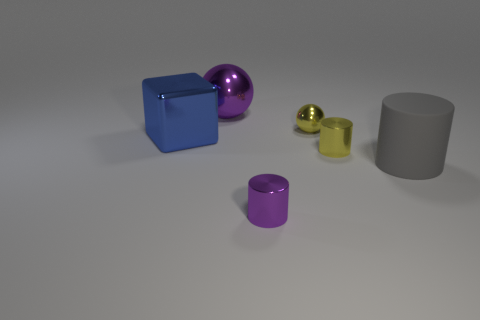Add 4 tiny balls. How many objects exist? 10 Subtract all cubes. How many objects are left? 5 Add 4 large shiny blocks. How many large shiny blocks exist? 5 Subtract 1 yellow cylinders. How many objects are left? 5 Subtract all small yellow matte blocks. Subtract all purple shiny cylinders. How many objects are left? 5 Add 2 yellow metallic cylinders. How many yellow metallic cylinders are left? 3 